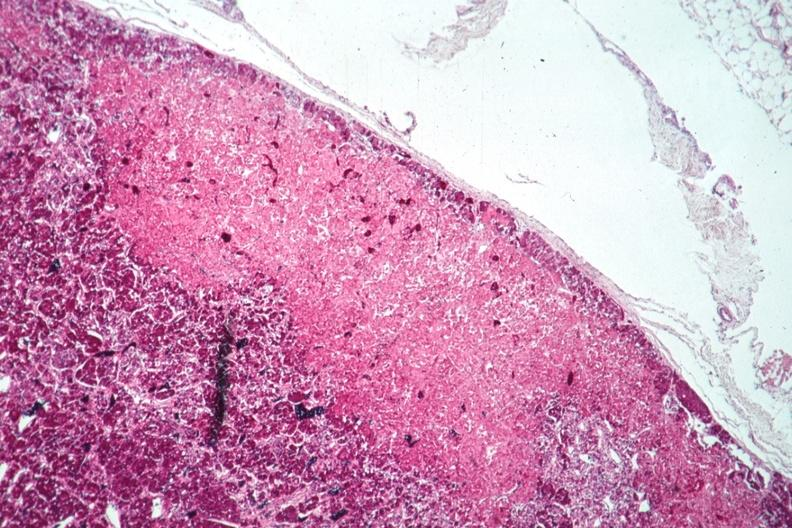s endocrine present?
Answer the question using a single word or phrase. No 